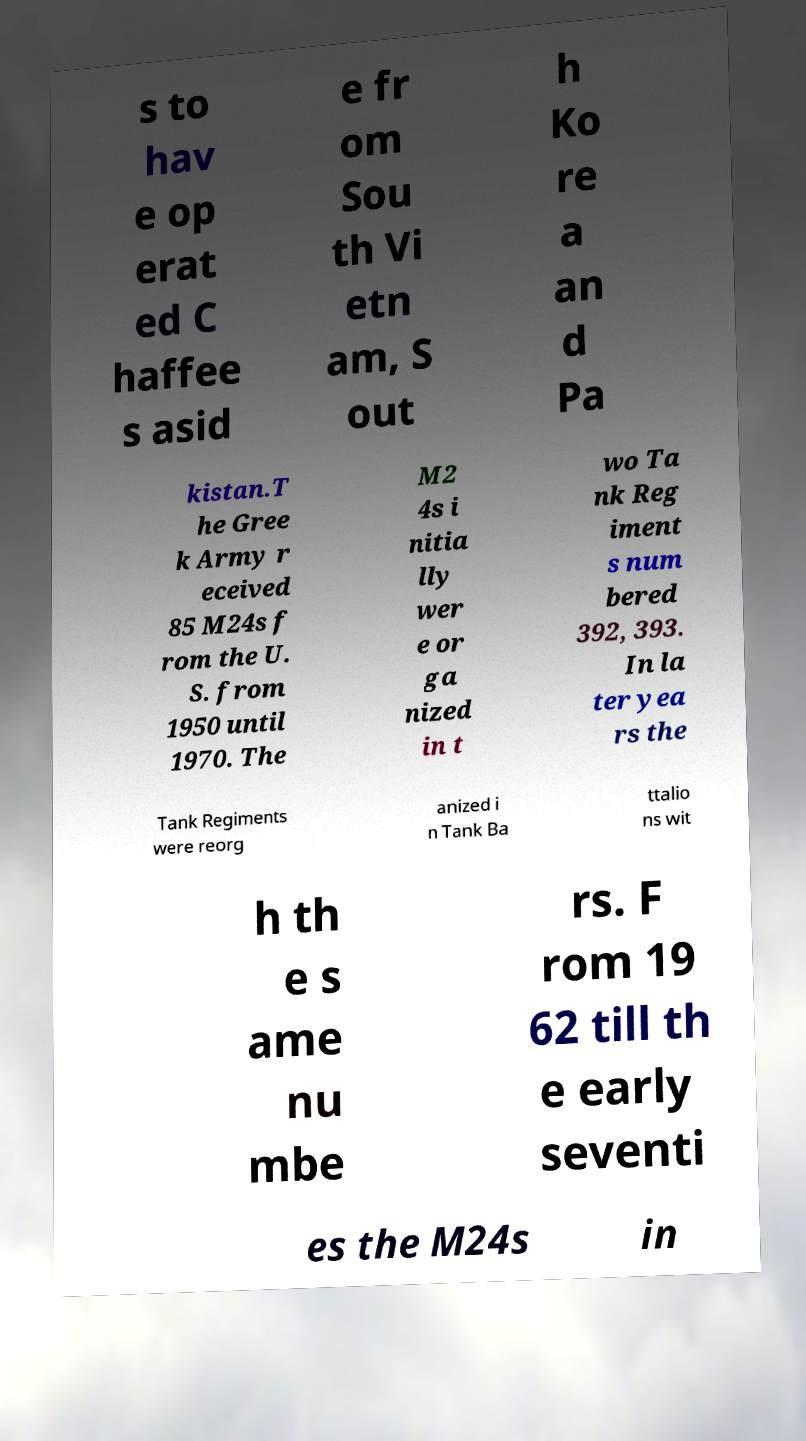Can you read and provide the text displayed in the image?This photo seems to have some interesting text. Can you extract and type it out for me? s to hav e op erat ed C haffee s asid e fr om Sou th Vi etn am, S out h Ko re a an d Pa kistan.T he Gree k Army r eceived 85 M24s f rom the U. S. from 1950 until 1970. The M2 4s i nitia lly wer e or ga nized in t wo Ta nk Reg iment s num bered 392, 393. In la ter yea rs the Tank Regiments were reorg anized i n Tank Ba ttalio ns wit h th e s ame nu mbe rs. F rom 19 62 till th e early seventi es the M24s in 